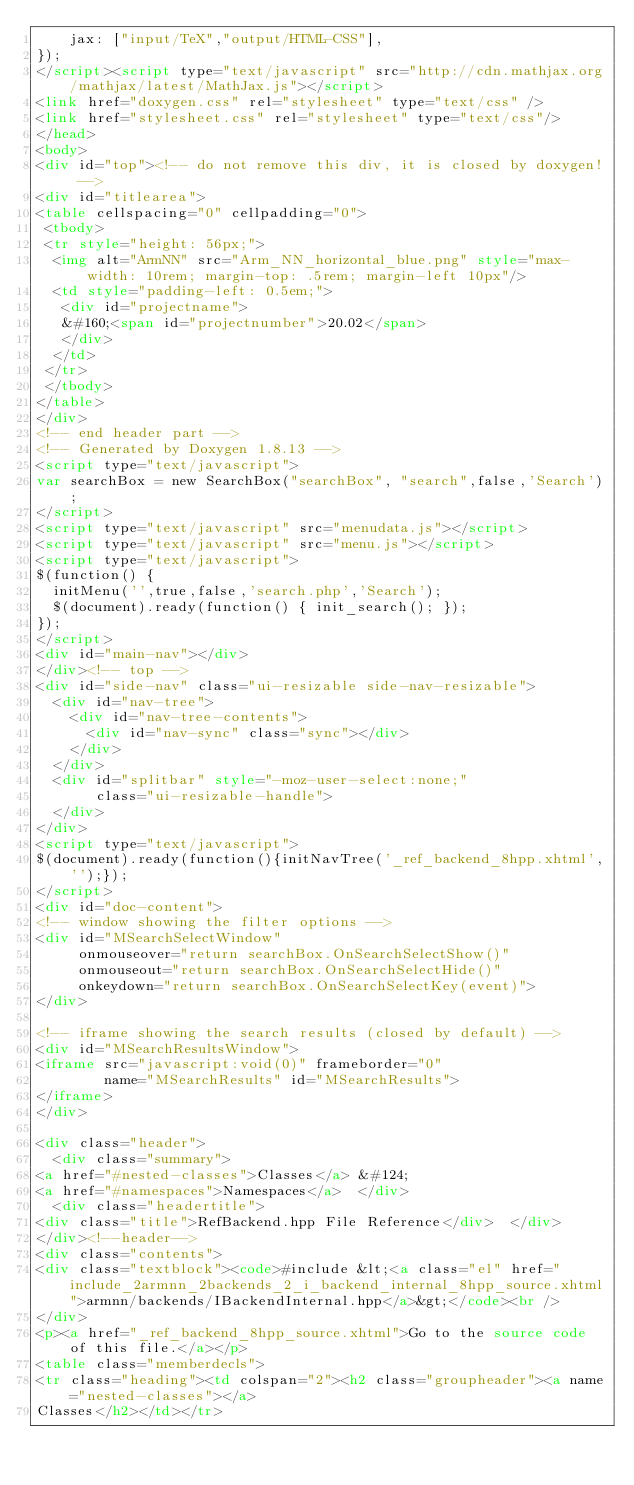Convert code to text. <code><loc_0><loc_0><loc_500><loc_500><_HTML_>    jax: ["input/TeX","output/HTML-CSS"],
});
</script><script type="text/javascript" src="http://cdn.mathjax.org/mathjax/latest/MathJax.js"></script>
<link href="doxygen.css" rel="stylesheet" type="text/css" />
<link href="stylesheet.css" rel="stylesheet" type="text/css"/>
</head>
<body>
<div id="top"><!-- do not remove this div, it is closed by doxygen! -->
<div id="titlearea">
<table cellspacing="0" cellpadding="0">
 <tbody>
 <tr style="height: 56px;">
  <img alt="ArmNN" src="Arm_NN_horizontal_blue.png" style="max-width: 10rem; margin-top: .5rem; margin-left 10px"/>
  <td style="padding-left: 0.5em;">
   <div id="projectname">
   &#160;<span id="projectnumber">20.02</span>
   </div>
  </td>
 </tr>
 </tbody>
</table>
</div>
<!-- end header part -->
<!-- Generated by Doxygen 1.8.13 -->
<script type="text/javascript">
var searchBox = new SearchBox("searchBox", "search",false,'Search');
</script>
<script type="text/javascript" src="menudata.js"></script>
<script type="text/javascript" src="menu.js"></script>
<script type="text/javascript">
$(function() {
  initMenu('',true,false,'search.php','Search');
  $(document).ready(function() { init_search(); });
});
</script>
<div id="main-nav"></div>
</div><!-- top -->
<div id="side-nav" class="ui-resizable side-nav-resizable">
  <div id="nav-tree">
    <div id="nav-tree-contents">
      <div id="nav-sync" class="sync"></div>
    </div>
  </div>
  <div id="splitbar" style="-moz-user-select:none;" 
       class="ui-resizable-handle">
  </div>
</div>
<script type="text/javascript">
$(document).ready(function(){initNavTree('_ref_backend_8hpp.xhtml','');});
</script>
<div id="doc-content">
<!-- window showing the filter options -->
<div id="MSearchSelectWindow"
     onmouseover="return searchBox.OnSearchSelectShow()"
     onmouseout="return searchBox.OnSearchSelectHide()"
     onkeydown="return searchBox.OnSearchSelectKey(event)">
</div>

<!-- iframe showing the search results (closed by default) -->
<div id="MSearchResultsWindow">
<iframe src="javascript:void(0)" frameborder="0" 
        name="MSearchResults" id="MSearchResults">
</iframe>
</div>

<div class="header">
  <div class="summary">
<a href="#nested-classes">Classes</a> &#124;
<a href="#namespaces">Namespaces</a>  </div>
  <div class="headertitle">
<div class="title">RefBackend.hpp File Reference</div>  </div>
</div><!--header-->
<div class="contents">
<div class="textblock"><code>#include &lt;<a class="el" href="include_2armnn_2backends_2_i_backend_internal_8hpp_source.xhtml">armnn/backends/IBackendInternal.hpp</a>&gt;</code><br />
</div>
<p><a href="_ref_backend_8hpp_source.xhtml">Go to the source code of this file.</a></p>
<table class="memberdecls">
<tr class="heading"><td colspan="2"><h2 class="groupheader"><a name="nested-classes"></a>
Classes</h2></td></tr></code> 